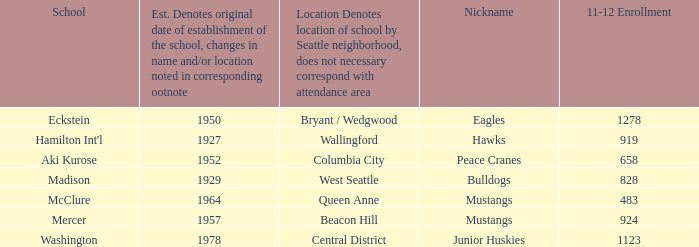Indicate the peak 11-12 attendance for columbia city. 658.0. Parse the table in full. {'header': ['School', 'Est. Denotes original date of establishment of the school, changes in name and/or location noted in corresponding ootnote', 'Location Denotes location of school by Seattle neighborhood, does not necessary correspond with attendance area', 'Nickname', '11-12 Enrollment'], 'rows': [['Eckstein', '1950', 'Bryant / Wedgwood', 'Eagles', '1278'], ["Hamilton Int'l", '1927', 'Wallingford', 'Hawks', '919'], ['Aki Kurose', '1952', 'Columbia City', 'Peace Cranes', '658'], ['Madison', '1929', 'West Seattle', 'Bulldogs', '828'], ['McClure', '1964', 'Queen Anne', 'Mustangs', '483'], ['Mercer', '1957', 'Beacon Hill', 'Mustangs', '924'], ['Washington', '1978', 'Central District', 'Junior Huskies', '1123']]} 